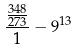Convert formula to latex. <formula><loc_0><loc_0><loc_500><loc_500>\frac { \frac { 3 4 8 } { 2 7 3 } } { 1 } - 9 ^ { 1 3 }</formula> 